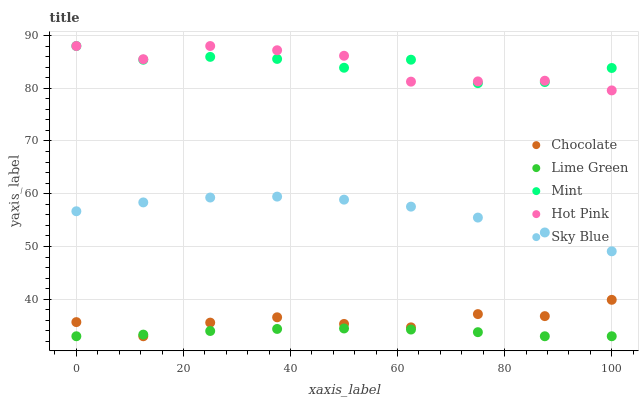Does Lime Green have the minimum area under the curve?
Answer yes or no. Yes. Does Hot Pink have the maximum area under the curve?
Answer yes or no. Yes. Does Sky Blue have the minimum area under the curve?
Answer yes or no. No. Does Sky Blue have the maximum area under the curve?
Answer yes or no. No. Is Lime Green the smoothest?
Answer yes or no. Yes. Is Mint the roughest?
Answer yes or no. Yes. Is Sky Blue the smoothest?
Answer yes or no. No. Is Sky Blue the roughest?
Answer yes or no. No. Does Lime Green have the lowest value?
Answer yes or no. Yes. Does Sky Blue have the lowest value?
Answer yes or no. No. Does Hot Pink have the highest value?
Answer yes or no. Yes. Does Sky Blue have the highest value?
Answer yes or no. No. Is Sky Blue less than Hot Pink?
Answer yes or no. Yes. Is Sky Blue greater than Lime Green?
Answer yes or no. Yes. Does Lime Green intersect Chocolate?
Answer yes or no. Yes. Is Lime Green less than Chocolate?
Answer yes or no. No. Is Lime Green greater than Chocolate?
Answer yes or no. No. Does Sky Blue intersect Hot Pink?
Answer yes or no. No. 